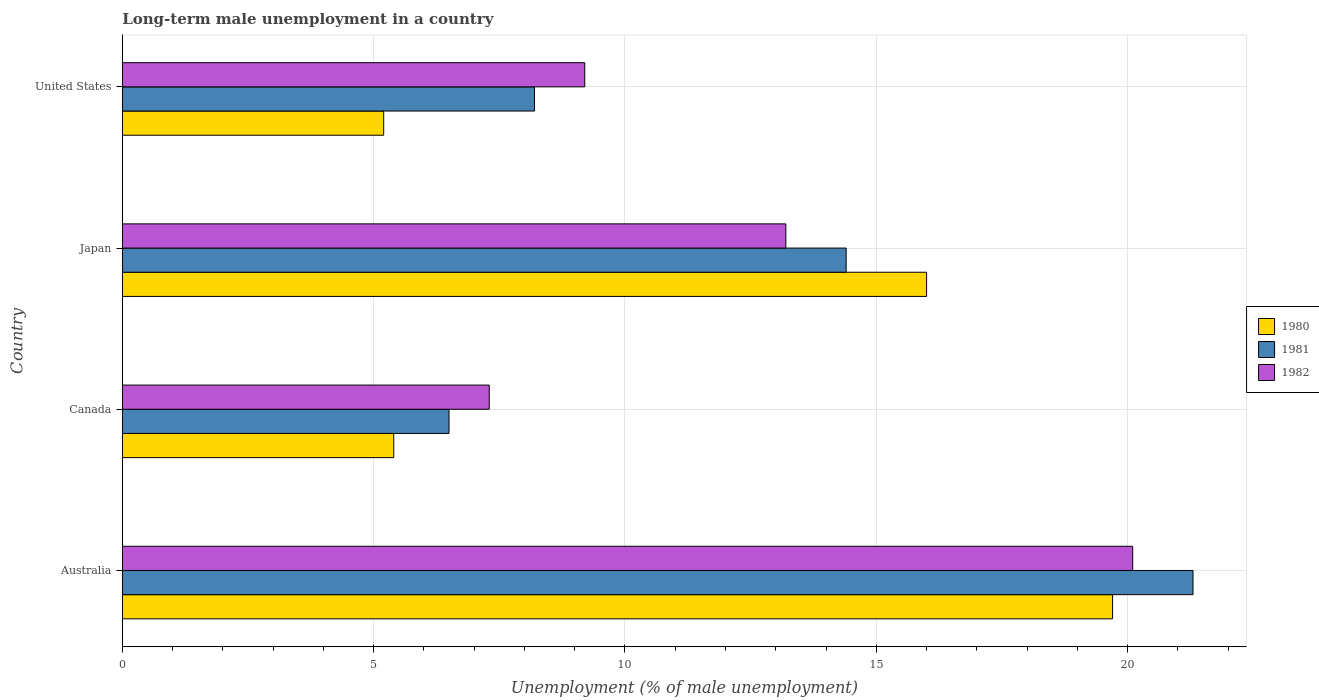How many different coloured bars are there?
Provide a succinct answer. 3. How many bars are there on the 1st tick from the bottom?
Give a very brief answer. 3. What is the percentage of long-term unemployed male population in 1981 in Japan?
Ensure brevity in your answer.  14.4. Across all countries, what is the maximum percentage of long-term unemployed male population in 1980?
Provide a succinct answer. 19.7. Across all countries, what is the minimum percentage of long-term unemployed male population in 1981?
Offer a terse response. 6.5. In which country was the percentage of long-term unemployed male population in 1980 maximum?
Offer a very short reply. Australia. What is the total percentage of long-term unemployed male population in 1982 in the graph?
Make the answer very short. 49.8. What is the difference between the percentage of long-term unemployed male population in 1982 in Australia and that in United States?
Your answer should be compact. 10.9. What is the difference between the percentage of long-term unemployed male population in 1981 in Japan and the percentage of long-term unemployed male population in 1982 in Australia?
Ensure brevity in your answer.  -5.7. What is the average percentage of long-term unemployed male population in 1982 per country?
Make the answer very short. 12.45. What is the difference between the percentage of long-term unemployed male population in 1982 and percentage of long-term unemployed male population in 1981 in United States?
Offer a very short reply. 1. In how many countries, is the percentage of long-term unemployed male population in 1982 greater than 14 %?
Your answer should be compact. 1. What is the ratio of the percentage of long-term unemployed male population in 1980 in Australia to that in United States?
Your answer should be very brief. 3.79. Is the difference between the percentage of long-term unemployed male population in 1982 in Australia and Canada greater than the difference between the percentage of long-term unemployed male population in 1981 in Australia and Canada?
Keep it short and to the point. No. What is the difference between the highest and the second highest percentage of long-term unemployed male population in 1980?
Your answer should be very brief. 3.7. What is the difference between the highest and the lowest percentage of long-term unemployed male population in 1981?
Ensure brevity in your answer.  14.8. Is the sum of the percentage of long-term unemployed male population in 1981 in Australia and Japan greater than the maximum percentage of long-term unemployed male population in 1982 across all countries?
Keep it short and to the point. Yes. What does the 2nd bar from the top in Australia represents?
Offer a very short reply. 1981. How many countries are there in the graph?
Give a very brief answer. 4. What is the difference between two consecutive major ticks on the X-axis?
Keep it short and to the point. 5. Are the values on the major ticks of X-axis written in scientific E-notation?
Your answer should be very brief. No. How are the legend labels stacked?
Make the answer very short. Vertical. What is the title of the graph?
Provide a succinct answer. Long-term male unemployment in a country. Does "1985" appear as one of the legend labels in the graph?
Keep it short and to the point. No. What is the label or title of the X-axis?
Provide a short and direct response. Unemployment (% of male unemployment). What is the label or title of the Y-axis?
Make the answer very short. Country. What is the Unemployment (% of male unemployment) of 1980 in Australia?
Ensure brevity in your answer.  19.7. What is the Unemployment (% of male unemployment) of 1981 in Australia?
Offer a very short reply. 21.3. What is the Unemployment (% of male unemployment) in 1982 in Australia?
Keep it short and to the point. 20.1. What is the Unemployment (% of male unemployment) of 1980 in Canada?
Your answer should be very brief. 5.4. What is the Unemployment (% of male unemployment) in 1981 in Canada?
Make the answer very short. 6.5. What is the Unemployment (% of male unemployment) in 1982 in Canada?
Offer a terse response. 7.3. What is the Unemployment (% of male unemployment) of 1981 in Japan?
Make the answer very short. 14.4. What is the Unemployment (% of male unemployment) of 1982 in Japan?
Keep it short and to the point. 13.2. What is the Unemployment (% of male unemployment) of 1980 in United States?
Make the answer very short. 5.2. What is the Unemployment (% of male unemployment) in 1981 in United States?
Your response must be concise. 8.2. What is the Unemployment (% of male unemployment) of 1982 in United States?
Your answer should be very brief. 9.2. Across all countries, what is the maximum Unemployment (% of male unemployment) of 1980?
Ensure brevity in your answer.  19.7. Across all countries, what is the maximum Unemployment (% of male unemployment) in 1981?
Offer a very short reply. 21.3. Across all countries, what is the maximum Unemployment (% of male unemployment) in 1982?
Offer a very short reply. 20.1. Across all countries, what is the minimum Unemployment (% of male unemployment) in 1980?
Make the answer very short. 5.2. Across all countries, what is the minimum Unemployment (% of male unemployment) of 1982?
Offer a terse response. 7.3. What is the total Unemployment (% of male unemployment) in 1980 in the graph?
Your answer should be compact. 46.3. What is the total Unemployment (% of male unemployment) in 1981 in the graph?
Give a very brief answer. 50.4. What is the total Unemployment (% of male unemployment) of 1982 in the graph?
Offer a terse response. 49.8. What is the difference between the Unemployment (% of male unemployment) in 1980 in Australia and that in Japan?
Give a very brief answer. 3.7. What is the difference between the Unemployment (% of male unemployment) of 1981 in Australia and that in Japan?
Offer a very short reply. 6.9. What is the difference between the Unemployment (% of male unemployment) in 1982 in Australia and that in Japan?
Your response must be concise. 6.9. What is the difference between the Unemployment (% of male unemployment) in 1981 in Australia and that in United States?
Offer a very short reply. 13.1. What is the difference between the Unemployment (% of male unemployment) of 1982 in Australia and that in United States?
Keep it short and to the point. 10.9. What is the difference between the Unemployment (% of male unemployment) of 1980 in Canada and that in United States?
Your answer should be compact. 0.2. What is the difference between the Unemployment (% of male unemployment) of 1981 in Japan and that in United States?
Offer a terse response. 6.2. What is the difference between the Unemployment (% of male unemployment) of 1982 in Japan and that in United States?
Make the answer very short. 4. What is the difference between the Unemployment (% of male unemployment) in 1981 in Australia and the Unemployment (% of male unemployment) in 1982 in Canada?
Offer a terse response. 14. What is the difference between the Unemployment (% of male unemployment) in 1980 in Australia and the Unemployment (% of male unemployment) in 1981 in Japan?
Your answer should be compact. 5.3. What is the difference between the Unemployment (% of male unemployment) of 1980 in Australia and the Unemployment (% of male unemployment) of 1982 in Japan?
Your answer should be compact. 6.5. What is the difference between the Unemployment (% of male unemployment) in 1981 in Australia and the Unemployment (% of male unemployment) in 1982 in Japan?
Your answer should be compact. 8.1. What is the difference between the Unemployment (% of male unemployment) in 1980 in Australia and the Unemployment (% of male unemployment) in 1981 in United States?
Your answer should be very brief. 11.5. What is the difference between the Unemployment (% of male unemployment) of 1980 in Australia and the Unemployment (% of male unemployment) of 1982 in United States?
Offer a very short reply. 10.5. What is the difference between the Unemployment (% of male unemployment) of 1981 in Australia and the Unemployment (% of male unemployment) of 1982 in United States?
Make the answer very short. 12.1. What is the difference between the Unemployment (% of male unemployment) in 1980 in Canada and the Unemployment (% of male unemployment) in 1982 in Japan?
Your answer should be very brief. -7.8. What is the difference between the Unemployment (% of male unemployment) of 1980 in Canada and the Unemployment (% of male unemployment) of 1981 in United States?
Your response must be concise. -2.8. What is the difference between the Unemployment (% of male unemployment) in 1980 in Canada and the Unemployment (% of male unemployment) in 1982 in United States?
Ensure brevity in your answer.  -3.8. What is the difference between the Unemployment (% of male unemployment) of 1980 in Japan and the Unemployment (% of male unemployment) of 1982 in United States?
Your answer should be very brief. 6.8. What is the average Unemployment (% of male unemployment) in 1980 per country?
Offer a terse response. 11.57. What is the average Unemployment (% of male unemployment) of 1981 per country?
Offer a very short reply. 12.6. What is the average Unemployment (% of male unemployment) of 1982 per country?
Keep it short and to the point. 12.45. What is the difference between the Unemployment (% of male unemployment) of 1980 and Unemployment (% of male unemployment) of 1981 in Australia?
Your answer should be compact. -1.6. What is the difference between the Unemployment (% of male unemployment) in 1980 and Unemployment (% of male unemployment) in 1982 in Australia?
Keep it short and to the point. -0.4. What is the difference between the Unemployment (% of male unemployment) in 1980 and Unemployment (% of male unemployment) in 1981 in Canada?
Ensure brevity in your answer.  -1.1. What is the difference between the Unemployment (% of male unemployment) in 1980 and Unemployment (% of male unemployment) in 1982 in Canada?
Make the answer very short. -1.9. What is the difference between the Unemployment (% of male unemployment) in 1980 and Unemployment (% of male unemployment) in 1981 in Japan?
Offer a terse response. 1.6. What is the difference between the Unemployment (% of male unemployment) in 1980 and Unemployment (% of male unemployment) in 1981 in United States?
Your answer should be compact. -3. What is the difference between the Unemployment (% of male unemployment) of 1981 and Unemployment (% of male unemployment) of 1982 in United States?
Provide a succinct answer. -1. What is the ratio of the Unemployment (% of male unemployment) of 1980 in Australia to that in Canada?
Provide a short and direct response. 3.65. What is the ratio of the Unemployment (% of male unemployment) of 1981 in Australia to that in Canada?
Your response must be concise. 3.28. What is the ratio of the Unemployment (% of male unemployment) of 1982 in Australia to that in Canada?
Offer a terse response. 2.75. What is the ratio of the Unemployment (% of male unemployment) in 1980 in Australia to that in Japan?
Your answer should be compact. 1.23. What is the ratio of the Unemployment (% of male unemployment) in 1981 in Australia to that in Japan?
Your answer should be compact. 1.48. What is the ratio of the Unemployment (% of male unemployment) in 1982 in Australia to that in Japan?
Keep it short and to the point. 1.52. What is the ratio of the Unemployment (% of male unemployment) of 1980 in Australia to that in United States?
Ensure brevity in your answer.  3.79. What is the ratio of the Unemployment (% of male unemployment) of 1981 in Australia to that in United States?
Ensure brevity in your answer.  2.6. What is the ratio of the Unemployment (% of male unemployment) in 1982 in Australia to that in United States?
Ensure brevity in your answer.  2.18. What is the ratio of the Unemployment (% of male unemployment) of 1980 in Canada to that in Japan?
Your answer should be compact. 0.34. What is the ratio of the Unemployment (% of male unemployment) in 1981 in Canada to that in Japan?
Your response must be concise. 0.45. What is the ratio of the Unemployment (% of male unemployment) in 1982 in Canada to that in Japan?
Keep it short and to the point. 0.55. What is the ratio of the Unemployment (% of male unemployment) of 1980 in Canada to that in United States?
Your answer should be compact. 1.04. What is the ratio of the Unemployment (% of male unemployment) in 1981 in Canada to that in United States?
Keep it short and to the point. 0.79. What is the ratio of the Unemployment (% of male unemployment) in 1982 in Canada to that in United States?
Your answer should be compact. 0.79. What is the ratio of the Unemployment (% of male unemployment) in 1980 in Japan to that in United States?
Give a very brief answer. 3.08. What is the ratio of the Unemployment (% of male unemployment) of 1981 in Japan to that in United States?
Your answer should be very brief. 1.76. What is the ratio of the Unemployment (% of male unemployment) of 1982 in Japan to that in United States?
Provide a succinct answer. 1.43. What is the difference between the highest and the lowest Unemployment (% of male unemployment) in 1980?
Make the answer very short. 14.5. What is the difference between the highest and the lowest Unemployment (% of male unemployment) of 1982?
Offer a very short reply. 12.8. 